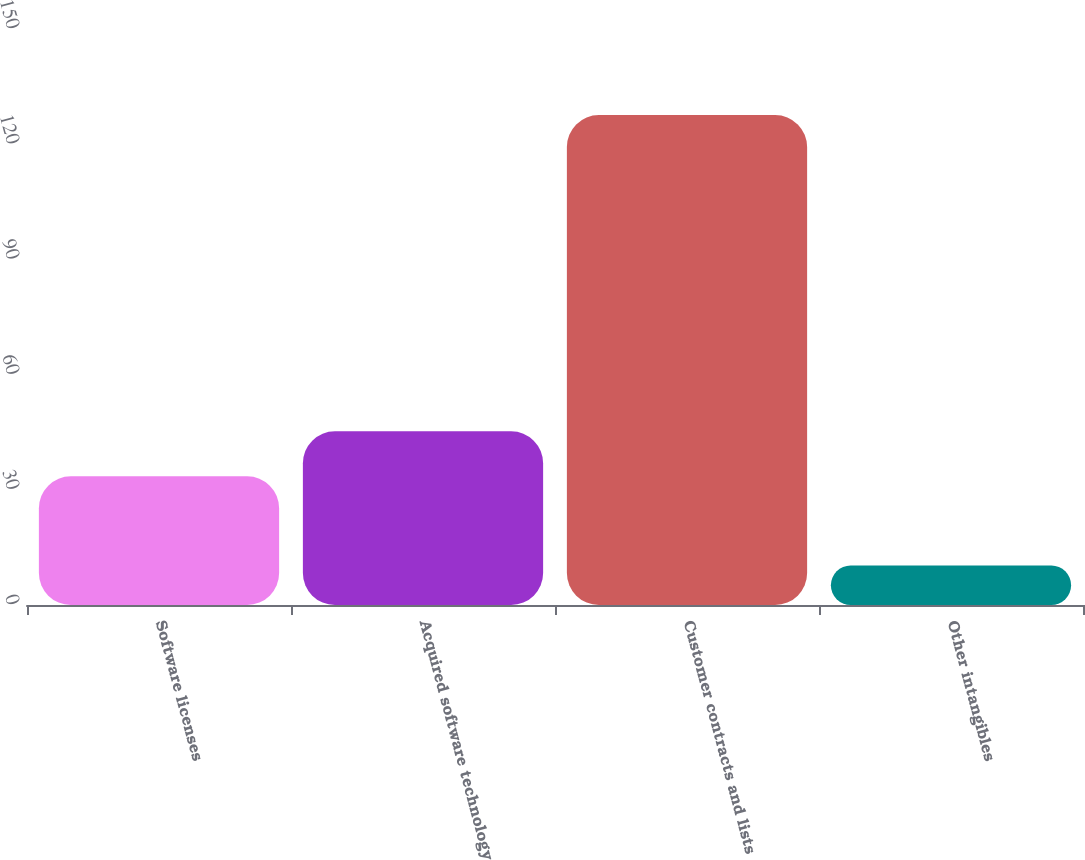Convert chart to OTSL. <chart><loc_0><loc_0><loc_500><loc_500><bar_chart><fcel>Software licenses<fcel>Acquired software technology<fcel>Customer contracts and lists<fcel>Other intangibles<nl><fcel>33.5<fcel>45.23<fcel>127.6<fcel>10.3<nl></chart> 